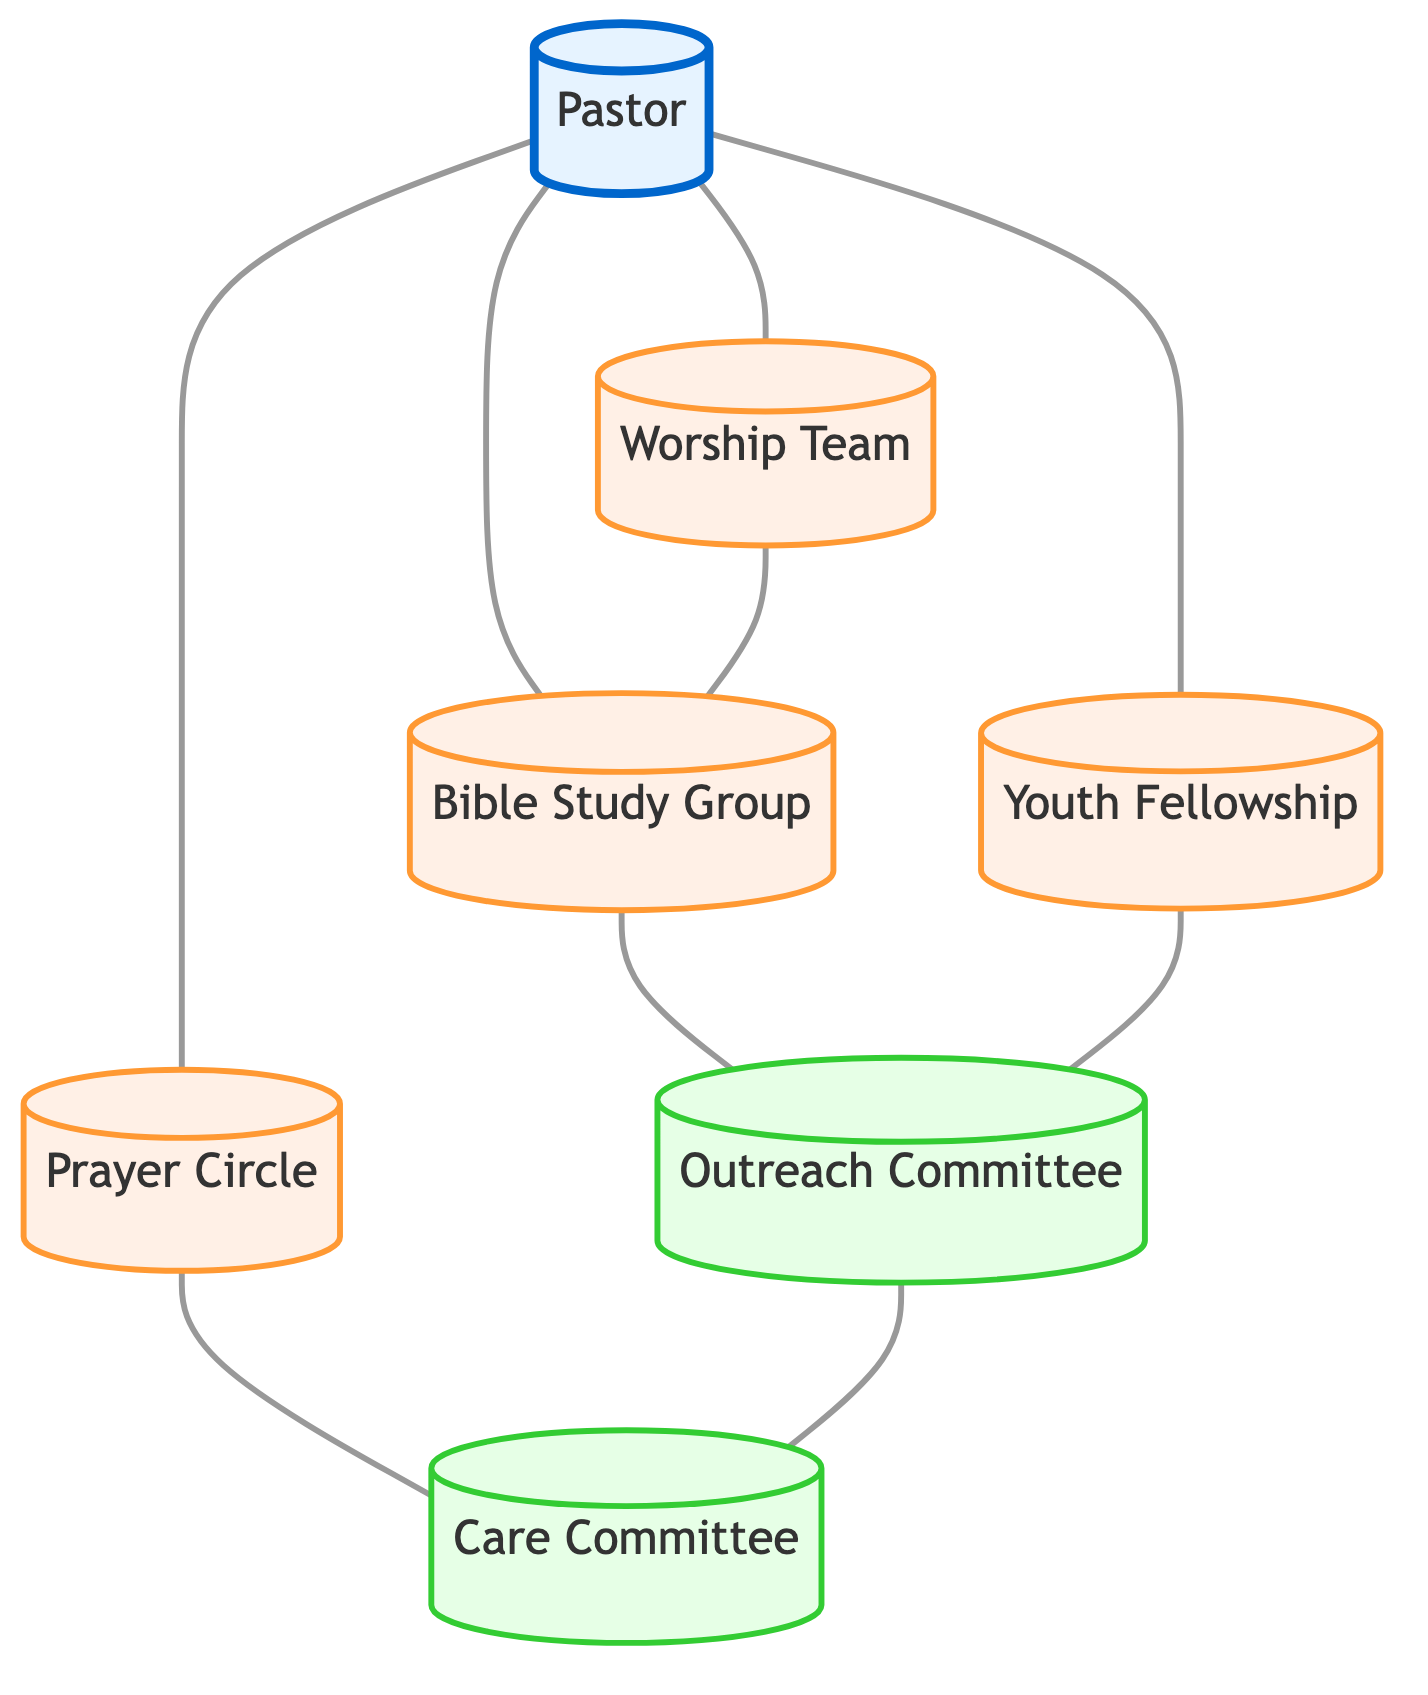What's the total number of nodes in the diagram? There are 7 nodes represented in the diagram: Pastor, Worship Team, Bible Study Group, Prayer Circle, Youth Fellowship, Outreach Committee, and Care Committee.
Answer: 7 Which group is directly connected to the Pastor? The Pastor is directly connected to the Worship Team, Bible Study Group, Prayer Circle, and Youth Fellowship. Each of these connections shows the Pastor's relationships with these groups.
Answer: Worship Team, Bible Study Group, Prayer Circle, Youth Fellowship How many connections are there from the Bible Study Group? The Bible Study Group has three connections: one to the Pastor, one to the Worship Team, and one to the Outreach Committee. Counting all these connections gives a total of three.
Answer: 3 What role does the Care Committee play in the network? The Care Committee provides support and assistance to church members in need. It is also connected to the Prayer Circle and the Outreach Committee, showing its community-oriented approach.
Answer: Provides support and assistance to church members in need Which groups are connected through the Outreach Committee? The Outreach Committee has direct connections with the Bible Study Group, Youth Fellowship, and Care Committee. It serves as a bridge between these groups for community service and evangelism activities.
Answer: Bible Study Group, Youth Fellowship, Care Committee What is the relationship between the Youth Fellowship and the Prayer Circle? The Youth Fellowship and Prayer Circle are not directly connected, but both connect to the Pastor. This indicates they may share common religious leadership but do not interact directly with each other.
Answer: No direct relationship Which group leads the congregation in worship? The Worship Team is responsible for leading the congregation in worship through music. This role is highlighted as crucial for the church's worship services.
Answer: Worship Team How many total edges (connections) are present in the diagram? There are 8 edges listed in the diagram, indicating the relationships between the 7 nodes. Each edge represents a connection between two groups.
Answer: 8 